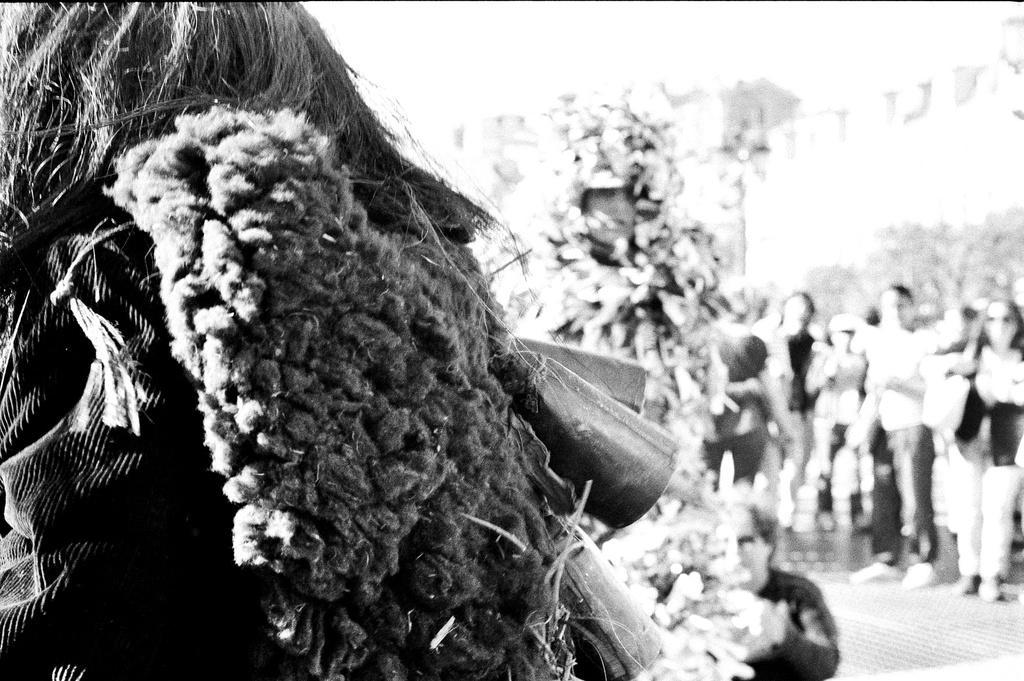Can you describe this image briefly? In this image we can see few persons, two of them wearing different costumes, background is blurred, and the picture is taken in black and white mode. 